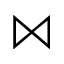Convert formula to latex. <formula><loc_0><loc_0><loc_500><loc_500>\ J o i n</formula> 